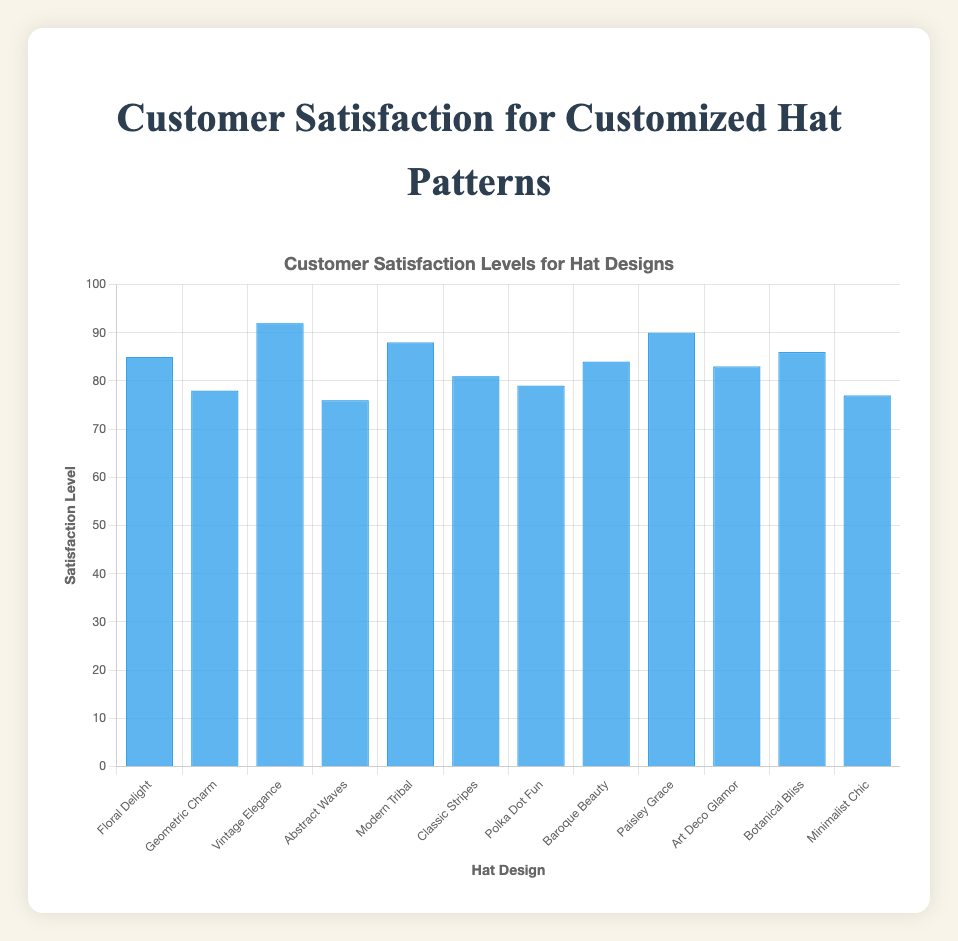What's the highest satisfaction level among the hat designs? The highest satisfaction level can be found by identifying the tallest blue bar and checking the corresponding value. The "Vintage Elegance" design has the tallest bar with a satisfaction level of 92.
Answer: 92 Which hat design has the lowest satisfaction level? The lowest satisfaction level can be found by identifying the shortest blue bar and checking the corresponding value. "Abstract Waves" has the shortest bar with a satisfaction level of 76.
Answer: Abstract Waves What is the average satisfaction level for all hat designs? To find the average, sum all satisfaction levels and divide by the number of hat designs. The total is \(85+78+92+76+88+81+79+84+90+83+86+77 = 999\). Dividing by 12 (the number of designs) gives \(999/12 \approx 83.25\).
Answer: 83.25 Which hat designs have a satisfaction level greater than 85? Examine the bars and identify those taller than the bar at the 85 mark. These designs are "Vintage Elegance" (92), "Modern Tribal" (88), "Paisley Grace" (90), and "Botanical Bliss" (86).
Answer: Vintage Elegance, Modern Tribal, Paisley Grace, Botanical Bliss Is the satisfaction level for "Classic Stripes" higher than for "Polka Dot Fun"? Compare the height of the bars for "Classic Stripes" and "Polka Dot Fun". "Classic Stripes" has a level of 81, while "Polka Dot Fun" has 79.
Answer: Yes What is the difference in satisfaction level between the highest and lowest design? Identify the highest (92 for "Vintage Elegance") and lowest (76 for "Abstract Waves") levels and find their difference. \(92 - 76 = 16\).
Answer: 16 How many designs have a satisfaction level equal to or above 80? Count the number of bars at 80 or higher. The designs are: "Floral Delight", "Vintage Elegance", "Modern Tribal", "Classic Stripes", "Baroque Beauty", "Paisley Grace", "Art Deco Glamor", and "Botanical Bliss", totaling 8.
Answer: 8 Which hat design has the most similar satisfaction level to "Minimalist Chic"? "Minimalist Chic" has a level of 77. Compare this to other values to find the closest one, which is "Abstract Waves" at 76.
Answer: Abstract Waves Is the satisfaction level for "Art Deco Glamor" above the average satisfaction level? The average satisfaction level is 83.25, and "Art Deco Glamor" has a level of 83. Since 83 < 83.25, it is below the average.
Answer: No What is the median satisfaction level for the hat designs? To find the median, the satisfaction levels must be ordered: 76, 77, 78, 79, 81, 83, 84, 85, 86, 88, 90, 92. With 12 values, the median is the average of the 6th and 7th values: \(83 + 84 = 167\), then \(167/2 = 83.5\).
Answer: 83.5 